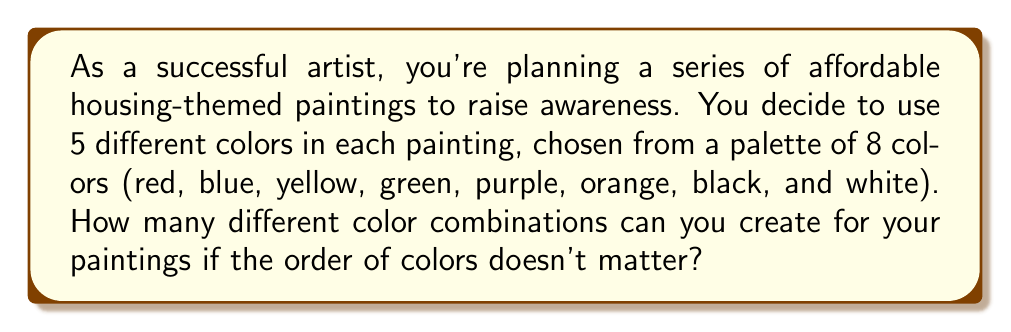Give your solution to this math problem. To solve this problem, we need to use the combination formula, as the order of colors doesn't matter. We are selecting 5 colors from a set of 8 colors.

The combination formula is:

$$ C(n,r) = \frac{n!}{r!(n-r)!} $$

Where:
$n$ is the total number of items to choose from (in this case, 8 colors)
$r$ is the number of items being chosen (in this case, 5 colors)

Let's substitute these values:

$$ C(8,5) = \frac{8!}{5!(8-5)!} = \frac{8!}{5!(3)!} $$

Now, let's calculate this step by step:

1) $8! = 8 \times 7 \times 6 \times 5 \times 4 \times 3 \times 2 \times 1 = 40,320$
2) $5! = 5 \times 4 \times 3 \times 2 \times 1 = 120$
3) $3! = 3 \times 2 \times 1 = 6$

Substituting these values:

$$ \frac{40,320}{120 \times 6} = \frac{40,320}{720} = 56 $$

Therefore, you can create 56 different color combinations for your affordable housing-themed paintings.
Answer: 56 different color combinations 